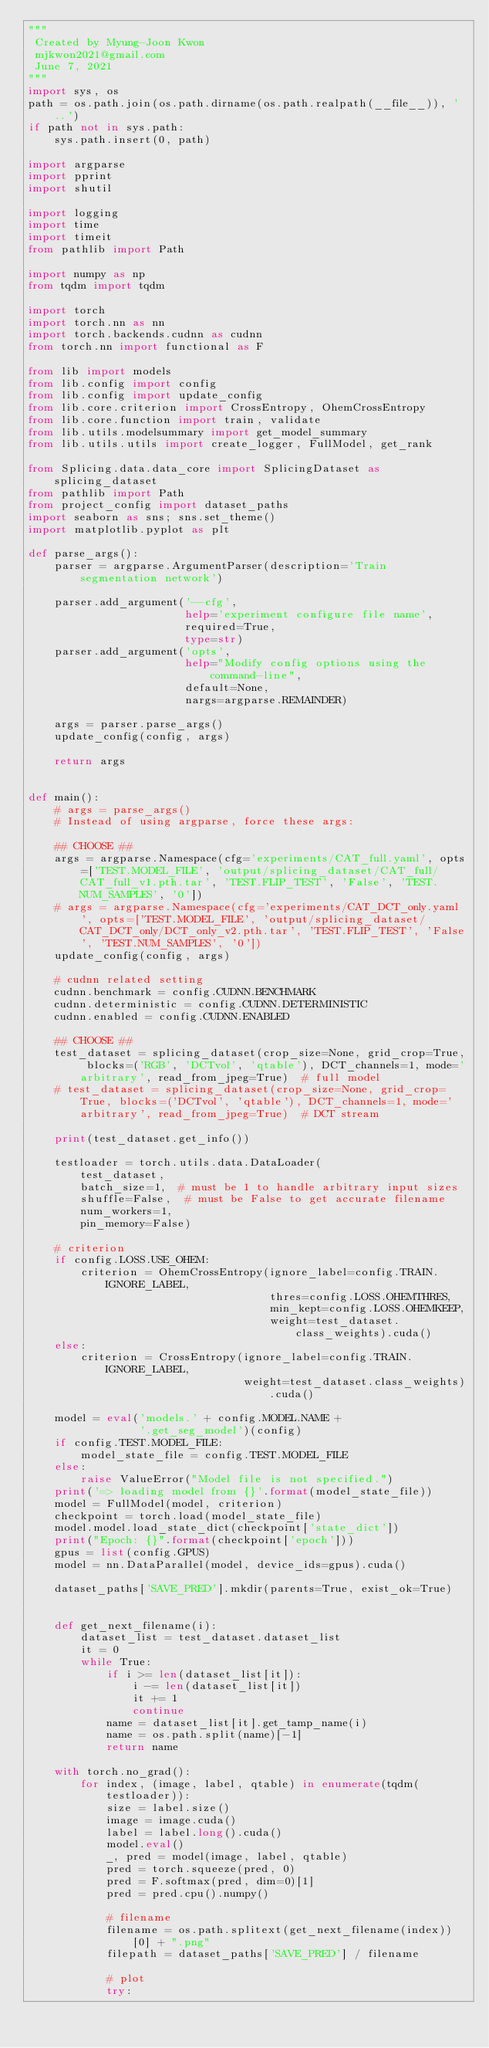<code> <loc_0><loc_0><loc_500><loc_500><_Python_>"""
 Created by Myung-Joon Kwon
 mjkwon2021@gmail.com
 June 7, 2021
"""
import sys, os
path = os.path.join(os.path.dirname(os.path.realpath(__file__)), '..')
if path not in sys.path:
    sys.path.insert(0, path)

import argparse
import pprint
import shutil

import logging
import time
import timeit
from pathlib import Path

import numpy as np
from tqdm import tqdm

import torch
import torch.nn as nn
import torch.backends.cudnn as cudnn
from torch.nn import functional as F

from lib import models
from lib.config import config
from lib.config import update_config
from lib.core.criterion import CrossEntropy, OhemCrossEntropy
from lib.core.function import train, validate
from lib.utils.modelsummary import get_model_summary
from lib.utils.utils import create_logger, FullModel, get_rank

from Splicing.data.data_core import SplicingDataset as splicing_dataset
from pathlib import Path
from project_config import dataset_paths
import seaborn as sns; sns.set_theme()
import matplotlib.pyplot as plt

def parse_args():
    parser = argparse.ArgumentParser(description='Train segmentation network')

    parser.add_argument('--cfg',
                        help='experiment configure file name',
                        required=True,
                        type=str)
    parser.add_argument('opts',
                        help="Modify config options using the command-line",
                        default=None,
                        nargs=argparse.REMAINDER)

    args = parser.parse_args()
    update_config(config, args)

    return args


def main():
    # args = parse_args()
    # Instead of using argparse, force these args:

    ## CHOOSE ##
    args = argparse.Namespace(cfg='experiments/CAT_full.yaml', opts=['TEST.MODEL_FILE', 'output/splicing_dataset/CAT_full/CAT_full_v1.pth.tar', 'TEST.FLIP_TEST', 'False', 'TEST.NUM_SAMPLES', '0'])
    # args = argparse.Namespace(cfg='experiments/CAT_DCT_only.yaml', opts=['TEST.MODEL_FILE', 'output/splicing_dataset/CAT_DCT_only/DCT_only_v2.pth.tar', 'TEST.FLIP_TEST', 'False', 'TEST.NUM_SAMPLES', '0'])
    update_config(config, args)

    # cudnn related setting
    cudnn.benchmark = config.CUDNN.BENCHMARK
    cudnn.deterministic = config.CUDNN.DETERMINISTIC
    cudnn.enabled = config.CUDNN.ENABLED

    ## CHOOSE ##
    test_dataset = splicing_dataset(crop_size=None, grid_crop=True, blocks=('RGB', 'DCTvol', 'qtable'), DCT_channels=1, mode='arbitrary', read_from_jpeg=True)  # full model
    # test_dataset = splicing_dataset(crop_size=None, grid_crop=True, blocks=('DCTvol', 'qtable'), DCT_channels=1, mode='arbitrary', read_from_jpeg=True)  # DCT stream

    print(test_dataset.get_info())

    testloader = torch.utils.data.DataLoader(
        test_dataset,
        batch_size=1,  # must be 1 to handle arbitrary input sizes
        shuffle=False,  # must be False to get accurate filename
        num_workers=1,
        pin_memory=False)

    # criterion
    if config.LOSS.USE_OHEM:
        criterion = OhemCrossEntropy(ignore_label=config.TRAIN.IGNORE_LABEL,
                                     thres=config.LOSS.OHEMTHRES,
                                     min_kept=config.LOSS.OHEMKEEP,
                                     weight=test_dataset.class_weights).cuda()
    else:
        criterion = CrossEntropy(ignore_label=config.TRAIN.IGNORE_LABEL,
                                 weight=test_dataset.class_weights).cuda()

    model = eval('models.' + config.MODEL.NAME +
                 '.get_seg_model')(config)
    if config.TEST.MODEL_FILE:
        model_state_file = config.TEST.MODEL_FILE
    else:
        raise ValueError("Model file is not specified.")
    print('=> loading model from {}'.format(model_state_file))
    model = FullModel(model, criterion)
    checkpoint = torch.load(model_state_file)
    model.model.load_state_dict(checkpoint['state_dict'])
    print("Epoch: {}".format(checkpoint['epoch']))
    gpus = list(config.GPUS)
    model = nn.DataParallel(model, device_ids=gpus).cuda()

    dataset_paths['SAVE_PRED'].mkdir(parents=True, exist_ok=True)


    def get_next_filename(i):
        dataset_list = test_dataset.dataset_list
        it = 0
        while True:
            if i >= len(dataset_list[it]):
                i -= len(dataset_list[it])
                it += 1
                continue
            name = dataset_list[it].get_tamp_name(i)
            name = os.path.split(name)[-1]
            return name

    with torch.no_grad():
        for index, (image, label, qtable) in enumerate(tqdm(testloader)):
            size = label.size()
            image = image.cuda()
            label = label.long().cuda()
            model.eval()
            _, pred = model(image, label, qtable)
            pred = torch.squeeze(pred, 0)
            pred = F.softmax(pred, dim=0)[1]
            pred = pred.cpu().numpy()

            # filename
            filename = os.path.splitext(get_next_filename(index))[0] + ".png"
            filepath = dataset_paths['SAVE_PRED'] / filename

            # plot
            try:</code> 